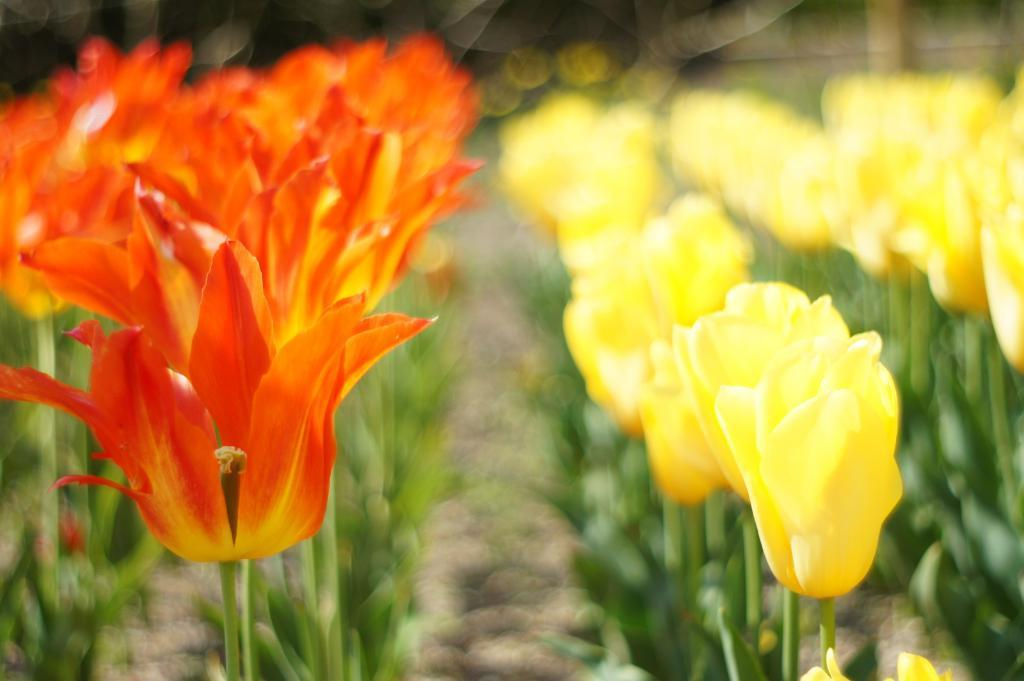What types of living organisms can be seen in the image? Plants and flowers are visible in the image. Can you describe the background of the image? The background of the image is blurry. How many cups can be seen in the image? There are no cups present in the image. Is there a person interacting with the plants in the image? There is no person visible in the image. What type of fowl is sitting on the flowers in the image? There is no fowl present in the image. 